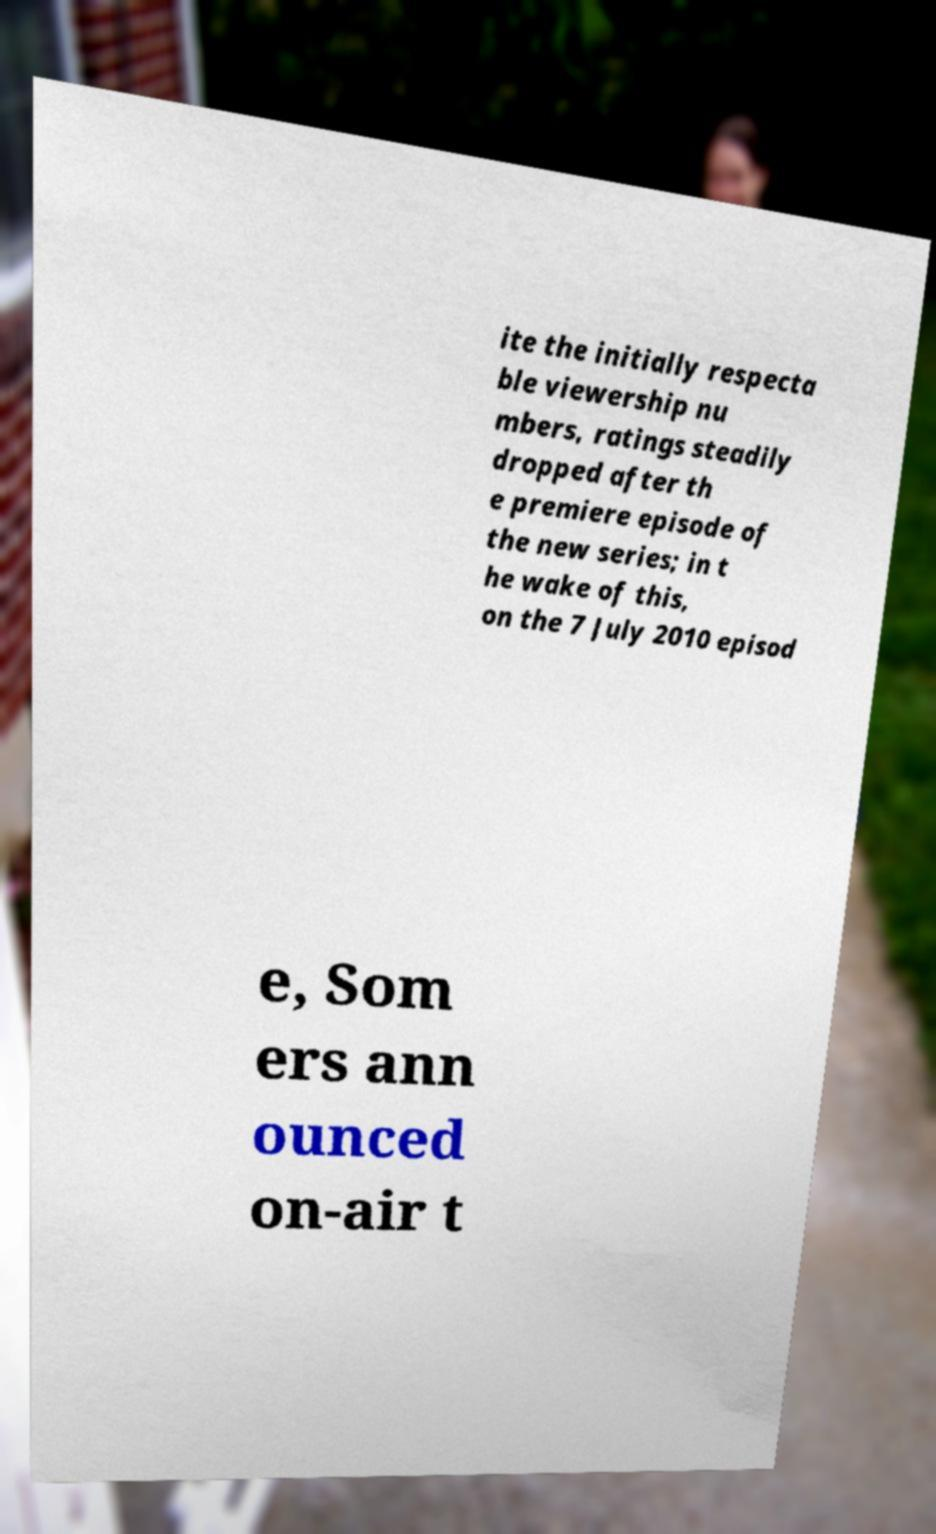There's text embedded in this image that I need extracted. Can you transcribe it verbatim? ite the initially respecta ble viewership nu mbers, ratings steadily dropped after th e premiere episode of the new series; in t he wake of this, on the 7 July 2010 episod e, Som ers ann ounced on-air t 